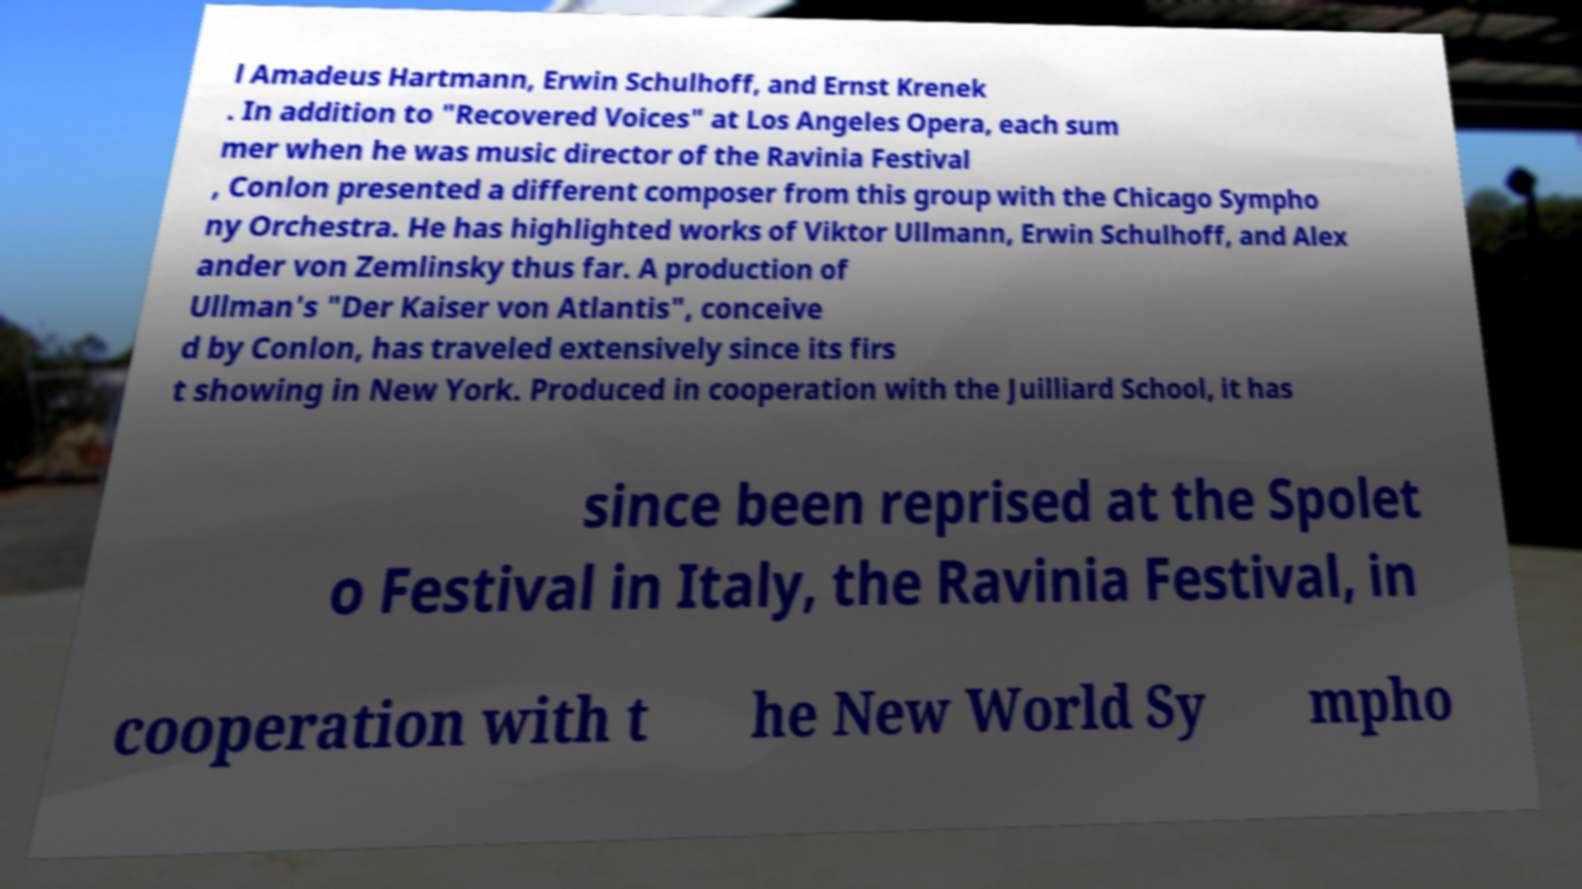For documentation purposes, I need the text within this image transcribed. Could you provide that? l Amadeus Hartmann, Erwin Schulhoff, and Ernst Krenek . In addition to "Recovered Voices" at Los Angeles Opera, each sum mer when he was music director of the Ravinia Festival , Conlon presented a different composer from this group with the Chicago Sympho ny Orchestra. He has highlighted works of Viktor Ullmann, Erwin Schulhoff, and Alex ander von Zemlinsky thus far. A production of Ullman's "Der Kaiser von Atlantis", conceive d by Conlon, has traveled extensively since its firs t showing in New York. Produced in cooperation with the Juilliard School, it has since been reprised at the Spolet o Festival in Italy, the Ravinia Festival, in cooperation with t he New World Sy mpho 